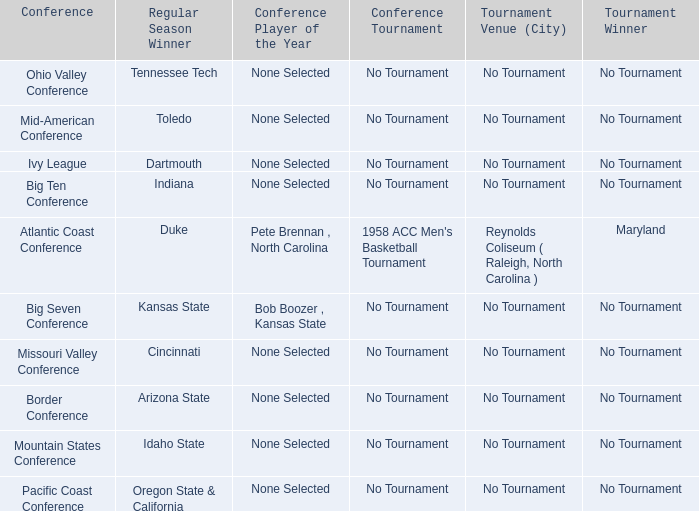Who was the winner of the regular season during the missouri valley conference event? Cincinnati. 